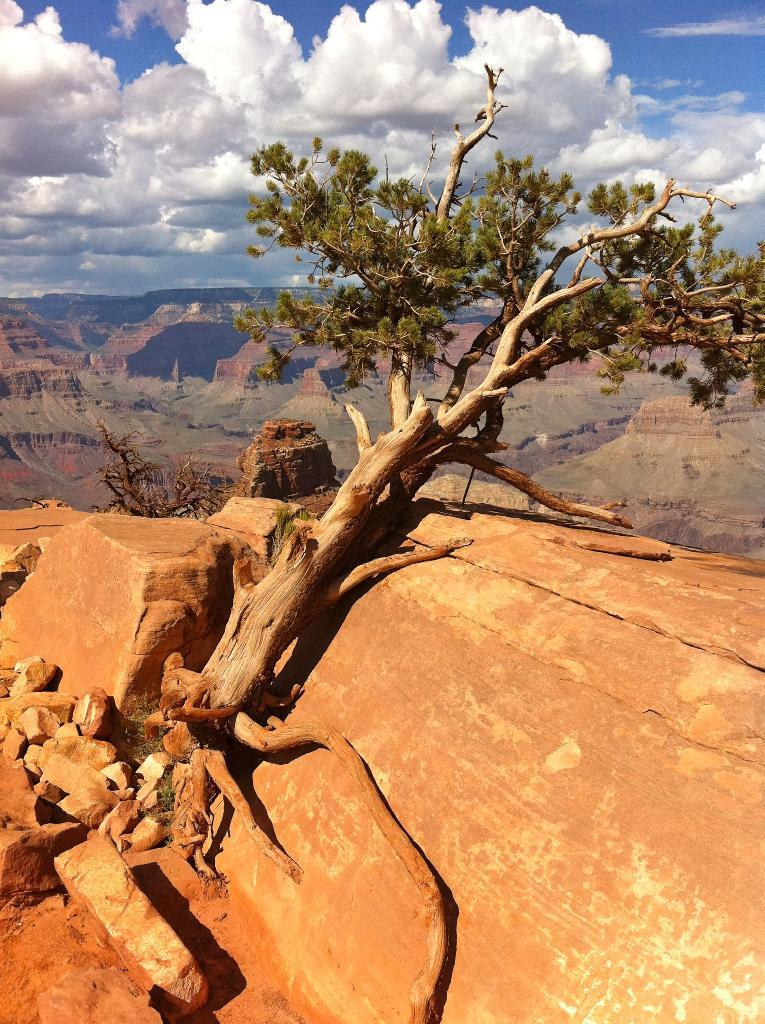What type of natural elements can be seen in the image? There are trees and hills visible in the image. What is visible at the top of the image? Clouds are visible at the top of the image. What holiday is being celebrated in the image? There is no indication of a holiday being celebrated in the image. Can you see a group of people walking on the hills in the image? There are no people visible in the image, so it is not possible to see a group of people walking on the hills. 